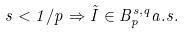Convert formula to latex. <formula><loc_0><loc_0><loc_500><loc_500>s < 1 / p \Rightarrow \tilde { I } \in B _ { p } ^ { s , q } a . s .</formula> 